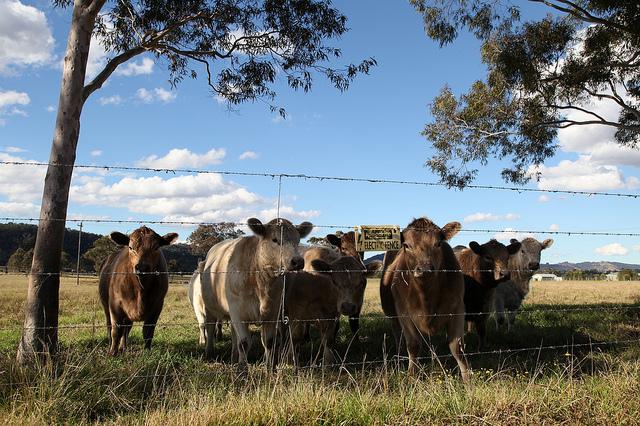Could the fence cut you?
Give a very brief answer. Yes. Do you think we can break through this fence?
Short answer required. No. How many trees?
Short answer required. 2. 